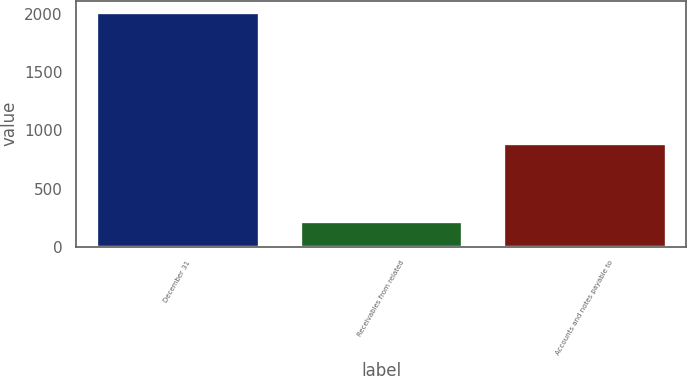<chart> <loc_0><loc_0><loc_500><loc_500><bar_chart><fcel>December 31<fcel>Receivables from related<fcel>Accounts and notes payable to<nl><fcel>2016<fcel>218<fcel>892<nl></chart> 